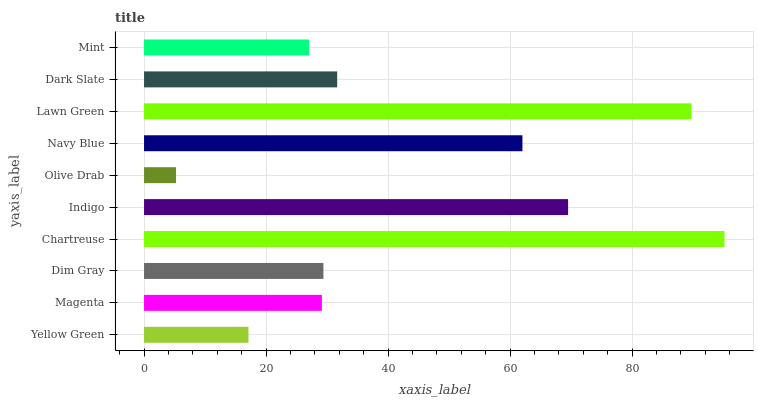Is Olive Drab the minimum?
Answer yes or no. Yes. Is Chartreuse the maximum?
Answer yes or no. Yes. Is Magenta the minimum?
Answer yes or no. No. Is Magenta the maximum?
Answer yes or no. No. Is Magenta greater than Yellow Green?
Answer yes or no. Yes. Is Yellow Green less than Magenta?
Answer yes or no. Yes. Is Yellow Green greater than Magenta?
Answer yes or no. No. Is Magenta less than Yellow Green?
Answer yes or no. No. Is Dark Slate the high median?
Answer yes or no. Yes. Is Dim Gray the low median?
Answer yes or no. Yes. Is Yellow Green the high median?
Answer yes or no. No. Is Indigo the low median?
Answer yes or no. No. 